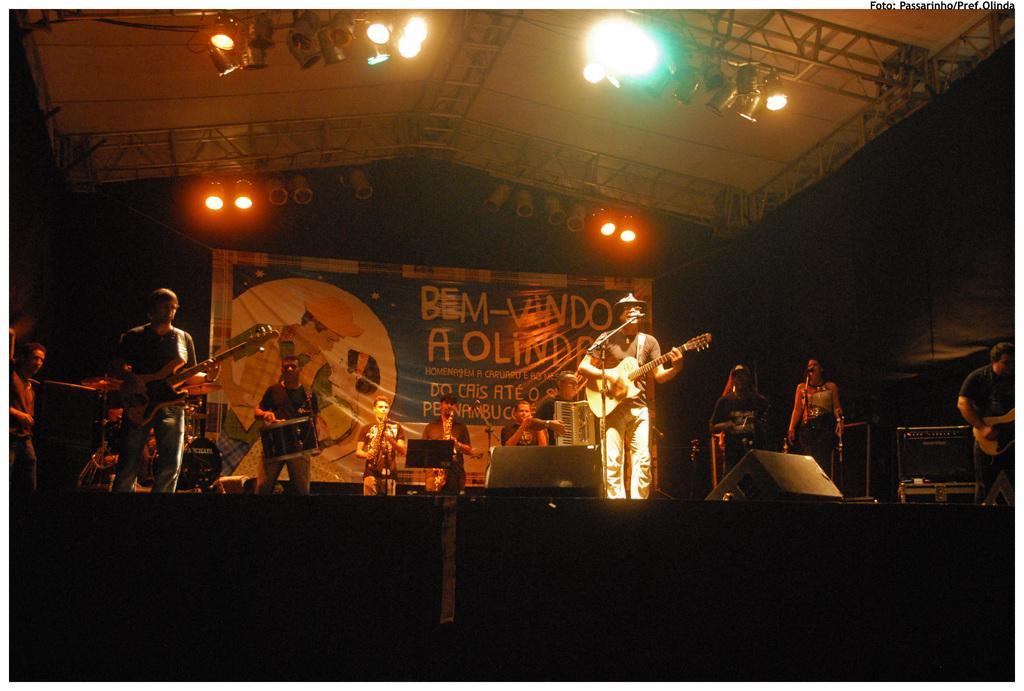In one or two sentences, can you explain what this image depicts? In the middle of this image, there are persons in different color dresses, standing on a stage. Some of them are playing musical instruments. On this stage, there are speakers and other objects arranged. Above this stage, there are lights attached to the roof. In the background, there is a banner. And the background is dark in color. 